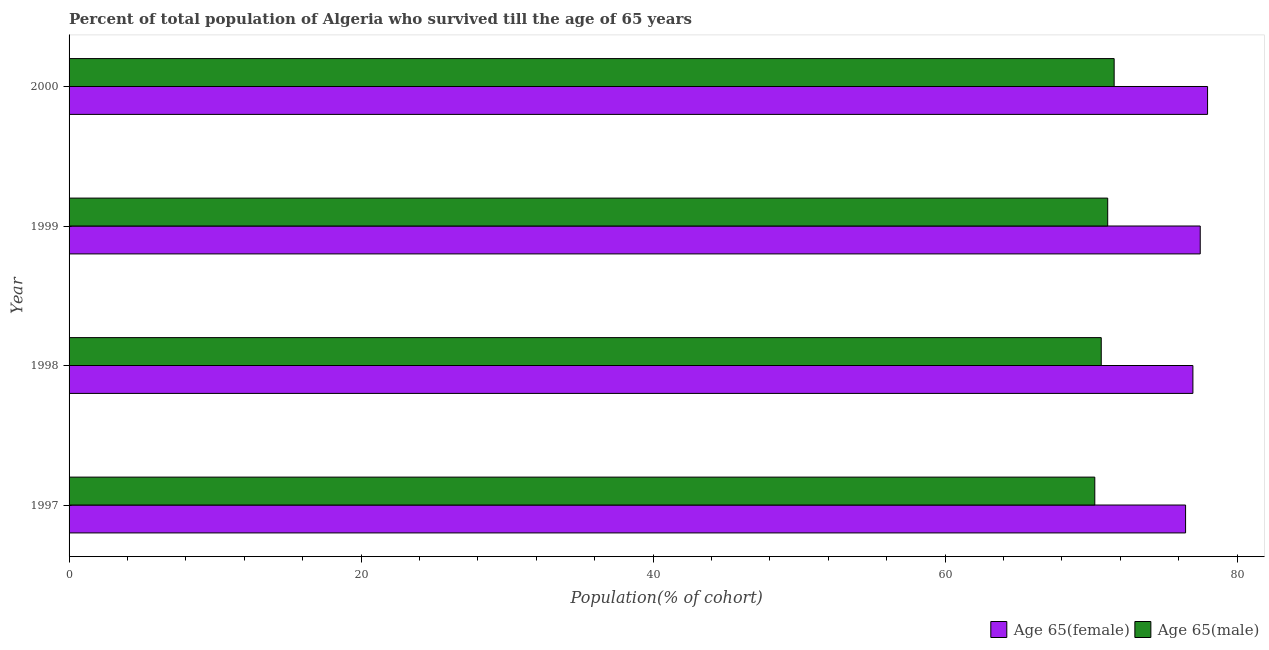How many different coloured bars are there?
Ensure brevity in your answer.  2. How many groups of bars are there?
Give a very brief answer. 4. Are the number of bars per tick equal to the number of legend labels?
Your response must be concise. Yes. Are the number of bars on each tick of the Y-axis equal?
Ensure brevity in your answer.  Yes. How many bars are there on the 1st tick from the top?
Offer a very short reply. 2. What is the label of the 3rd group of bars from the top?
Your answer should be very brief. 1998. What is the percentage of male population who survived till age of 65 in 1997?
Ensure brevity in your answer.  70.26. Across all years, what is the maximum percentage of male population who survived till age of 65?
Offer a terse response. 71.58. Across all years, what is the minimum percentage of female population who survived till age of 65?
Your answer should be very brief. 76.47. In which year was the percentage of female population who survived till age of 65 maximum?
Make the answer very short. 2000. What is the total percentage of female population who survived till age of 65 in the graph?
Your answer should be very brief. 308.91. What is the difference between the percentage of male population who survived till age of 65 in 1998 and that in 2000?
Your response must be concise. -0.88. What is the difference between the percentage of female population who survived till age of 65 in 1999 and the percentage of male population who survived till age of 65 in 1998?
Your response must be concise. 6.78. What is the average percentage of male population who survived till age of 65 per year?
Your answer should be compact. 70.92. In the year 1999, what is the difference between the percentage of female population who survived till age of 65 and percentage of male population who survived till age of 65?
Provide a short and direct response. 6.34. What is the ratio of the percentage of female population who survived till age of 65 in 1997 to that in 1999?
Ensure brevity in your answer.  0.99. What is the difference between the highest and the second highest percentage of male population who survived till age of 65?
Give a very brief answer. 0.44. What is the difference between the highest and the lowest percentage of male population who survived till age of 65?
Your answer should be very brief. 1.33. Is the sum of the percentage of male population who survived till age of 65 in 1997 and 1998 greater than the maximum percentage of female population who survived till age of 65 across all years?
Provide a succinct answer. Yes. What does the 2nd bar from the top in 2000 represents?
Ensure brevity in your answer.  Age 65(female). What does the 2nd bar from the bottom in 2000 represents?
Provide a succinct answer. Age 65(male). How many bars are there?
Provide a succinct answer. 8. Does the graph contain any zero values?
Ensure brevity in your answer.  No. Where does the legend appear in the graph?
Provide a succinct answer. Bottom right. How many legend labels are there?
Provide a succinct answer. 2. What is the title of the graph?
Keep it short and to the point. Percent of total population of Algeria who survived till the age of 65 years. What is the label or title of the X-axis?
Provide a short and direct response. Population(% of cohort). What is the label or title of the Y-axis?
Offer a very short reply. Year. What is the Population(% of cohort) of Age 65(female) in 1997?
Ensure brevity in your answer.  76.47. What is the Population(% of cohort) of Age 65(male) in 1997?
Provide a short and direct response. 70.26. What is the Population(% of cohort) in Age 65(female) in 1998?
Your response must be concise. 76.98. What is the Population(% of cohort) in Age 65(male) in 1998?
Your answer should be compact. 70.7. What is the Population(% of cohort) in Age 65(female) in 1999?
Your answer should be very brief. 77.48. What is the Population(% of cohort) of Age 65(male) in 1999?
Provide a succinct answer. 71.14. What is the Population(% of cohort) of Age 65(female) in 2000?
Provide a short and direct response. 77.98. What is the Population(% of cohort) of Age 65(male) in 2000?
Your answer should be compact. 71.58. Across all years, what is the maximum Population(% of cohort) of Age 65(female)?
Offer a terse response. 77.98. Across all years, what is the maximum Population(% of cohort) of Age 65(male)?
Your answer should be compact. 71.58. Across all years, what is the minimum Population(% of cohort) of Age 65(female)?
Provide a succinct answer. 76.47. Across all years, what is the minimum Population(% of cohort) in Age 65(male)?
Provide a short and direct response. 70.26. What is the total Population(% of cohort) of Age 65(female) in the graph?
Make the answer very short. 308.91. What is the total Population(% of cohort) in Age 65(male) in the graph?
Give a very brief answer. 283.68. What is the difference between the Population(% of cohort) in Age 65(female) in 1997 and that in 1998?
Offer a terse response. -0.5. What is the difference between the Population(% of cohort) in Age 65(male) in 1997 and that in 1998?
Provide a short and direct response. -0.44. What is the difference between the Population(% of cohort) in Age 65(female) in 1997 and that in 1999?
Provide a short and direct response. -1. What is the difference between the Population(% of cohort) of Age 65(male) in 1997 and that in 1999?
Provide a short and direct response. -0.88. What is the difference between the Population(% of cohort) in Age 65(female) in 1997 and that in 2000?
Provide a succinct answer. -1.51. What is the difference between the Population(% of cohort) in Age 65(male) in 1997 and that in 2000?
Give a very brief answer. -1.33. What is the difference between the Population(% of cohort) of Age 65(female) in 1998 and that in 1999?
Ensure brevity in your answer.  -0.5. What is the difference between the Population(% of cohort) of Age 65(male) in 1998 and that in 1999?
Make the answer very short. -0.44. What is the difference between the Population(% of cohort) in Age 65(female) in 1998 and that in 2000?
Ensure brevity in your answer.  -1. What is the difference between the Population(% of cohort) in Age 65(male) in 1998 and that in 2000?
Offer a very short reply. -0.88. What is the difference between the Population(% of cohort) in Age 65(female) in 1999 and that in 2000?
Offer a terse response. -0.5. What is the difference between the Population(% of cohort) of Age 65(male) in 1999 and that in 2000?
Ensure brevity in your answer.  -0.44. What is the difference between the Population(% of cohort) of Age 65(female) in 1997 and the Population(% of cohort) of Age 65(male) in 1998?
Provide a succinct answer. 5.78. What is the difference between the Population(% of cohort) in Age 65(female) in 1997 and the Population(% of cohort) in Age 65(male) in 1999?
Your answer should be compact. 5.33. What is the difference between the Population(% of cohort) in Age 65(female) in 1997 and the Population(% of cohort) in Age 65(male) in 2000?
Give a very brief answer. 4.89. What is the difference between the Population(% of cohort) of Age 65(female) in 1998 and the Population(% of cohort) of Age 65(male) in 1999?
Provide a short and direct response. 5.84. What is the difference between the Population(% of cohort) in Age 65(female) in 1998 and the Population(% of cohort) in Age 65(male) in 2000?
Your answer should be very brief. 5.39. What is the difference between the Population(% of cohort) of Age 65(female) in 1999 and the Population(% of cohort) of Age 65(male) in 2000?
Give a very brief answer. 5.9. What is the average Population(% of cohort) in Age 65(female) per year?
Ensure brevity in your answer.  77.23. What is the average Population(% of cohort) in Age 65(male) per year?
Provide a short and direct response. 70.92. In the year 1997, what is the difference between the Population(% of cohort) of Age 65(female) and Population(% of cohort) of Age 65(male)?
Your answer should be very brief. 6.22. In the year 1998, what is the difference between the Population(% of cohort) in Age 65(female) and Population(% of cohort) in Age 65(male)?
Provide a short and direct response. 6.28. In the year 1999, what is the difference between the Population(% of cohort) of Age 65(female) and Population(% of cohort) of Age 65(male)?
Your response must be concise. 6.34. In the year 2000, what is the difference between the Population(% of cohort) in Age 65(female) and Population(% of cohort) in Age 65(male)?
Your response must be concise. 6.4. What is the ratio of the Population(% of cohort) in Age 65(male) in 1997 to that in 1998?
Ensure brevity in your answer.  0.99. What is the ratio of the Population(% of cohort) of Age 65(male) in 1997 to that in 1999?
Make the answer very short. 0.99. What is the ratio of the Population(% of cohort) in Age 65(female) in 1997 to that in 2000?
Keep it short and to the point. 0.98. What is the ratio of the Population(% of cohort) of Age 65(male) in 1997 to that in 2000?
Provide a succinct answer. 0.98. What is the ratio of the Population(% of cohort) of Age 65(male) in 1998 to that in 1999?
Provide a short and direct response. 0.99. What is the ratio of the Population(% of cohort) in Age 65(female) in 1998 to that in 2000?
Give a very brief answer. 0.99. What is the ratio of the Population(% of cohort) in Age 65(male) in 1999 to that in 2000?
Give a very brief answer. 0.99. What is the difference between the highest and the second highest Population(% of cohort) in Age 65(female)?
Give a very brief answer. 0.5. What is the difference between the highest and the second highest Population(% of cohort) of Age 65(male)?
Your answer should be very brief. 0.44. What is the difference between the highest and the lowest Population(% of cohort) of Age 65(female)?
Ensure brevity in your answer.  1.51. What is the difference between the highest and the lowest Population(% of cohort) of Age 65(male)?
Keep it short and to the point. 1.33. 